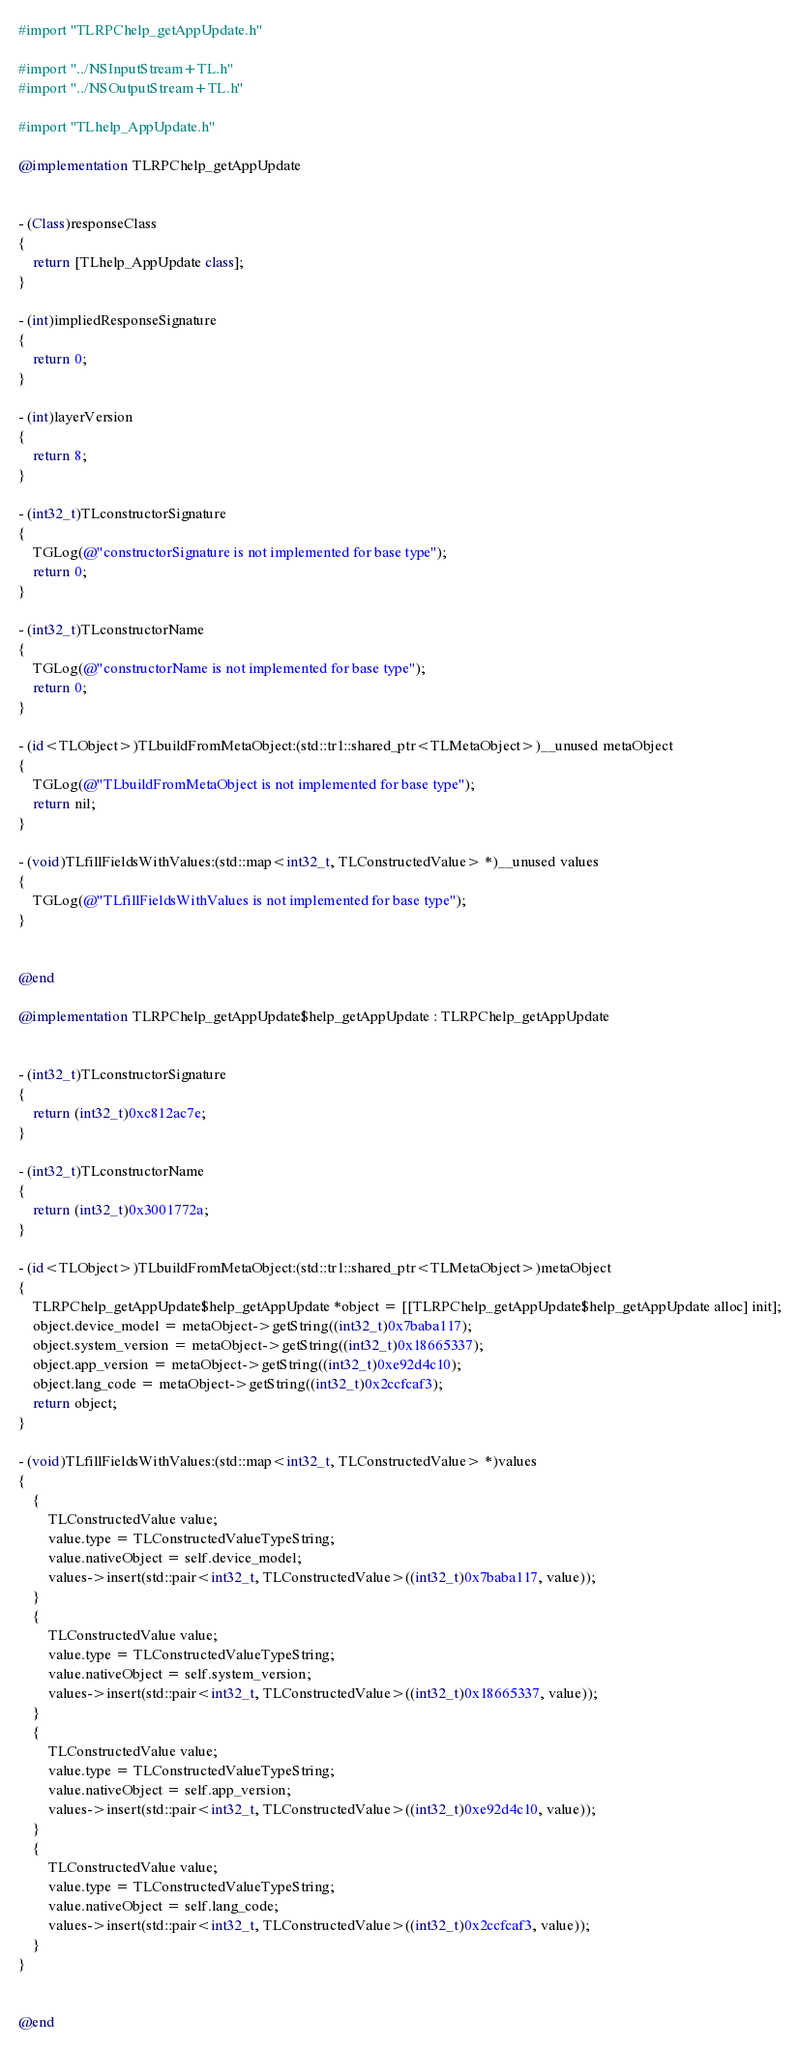Convert code to text. <code><loc_0><loc_0><loc_500><loc_500><_ObjectiveC_>#import "TLRPChelp_getAppUpdate.h"

#import "../NSInputStream+TL.h"
#import "../NSOutputStream+TL.h"

#import "TLhelp_AppUpdate.h"

@implementation TLRPChelp_getAppUpdate


- (Class)responseClass
{
    return [TLhelp_AppUpdate class];
}

- (int)impliedResponseSignature
{
    return 0;
}

- (int)layerVersion
{
    return 8;
}

- (int32_t)TLconstructorSignature
{
    TGLog(@"constructorSignature is not implemented for base type");
    return 0;
}

- (int32_t)TLconstructorName
{
    TGLog(@"constructorName is not implemented for base type");
    return 0;
}

- (id<TLObject>)TLbuildFromMetaObject:(std::tr1::shared_ptr<TLMetaObject>)__unused metaObject
{
    TGLog(@"TLbuildFromMetaObject is not implemented for base type");
    return nil;
}

- (void)TLfillFieldsWithValues:(std::map<int32_t, TLConstructedValue> *)__unused values
{
    TGLog(@"TLfillFieldsWithValues is not implemented for base type");
}


@end

@implementation TLRPChelp_getAppUpdate$help_getAppUpdate : TLRPChelp_getAppUpdate


- (int32_t)TLconstructorSignature
{
    return (int32_t)0xc812ac7e;
}

- (int32_t)TLconstructorName
{
    return (int32_t)0x3001772a;
}

- (id<TLObject>)TLbuildFromMetaObject:(std::tr1::shared_ptr<TLMetaObject>)metaObject
{
    TLRPChelp_getAppUpdate$help_getAppUpdate *object = [[TLRPChelp_getAppUpdate$help_getAppUpdate alloc] init];
    object.device_model = metaObject->getString((int32_t)0x7baba117);
    object.system_version = metaObject->getString((int32_t)0x18665337);
    object.app_version = metaObject->getString((int32_t)0xe92d4c10);
    object.lang_code = metaObject->getString((int32_t)0x2ccfcaf3);
    return object;
}

- (void)TLfillFieldsWithValues:(std::map<int32_t, TLConstructedValue> *)values
{
    {
        TLConstructedValue value;
        value.type = TLConstructedValueTypeString;
        value.nativeObject = self.device_model;
        values->insert(std::pair<int32_t, TLConstructedValue>((int32_t)0x7baba117, value));
    }
    {
        TLConstructedValue value;
        value.type = TLConstructedValueTypeString;
        value.nativeObject = self.system_version;
        values->insert(std::pair<int32_t, TLConstructedValue>((int32_t)0x18665337, value));
    }
    {
        TLConstructedValue value;
        value.type = TLConstructedValueTypeString;
        value.nativeObject = self.app_version;
        values->insert(std::pair<int32_t, TLConstructedValue>((int32_t)0xe92d4c10, value));
    }
    {
        TLConstructedValue value;
        value.type = TLConstructedValueTypeString;
        value.nativeObject = self.lang_code;
        values->insert(std::pair<int32_t, TLConstructedValue>((int32_t)0x2ccfcaf3, value));
    }
}


@end

</code> 